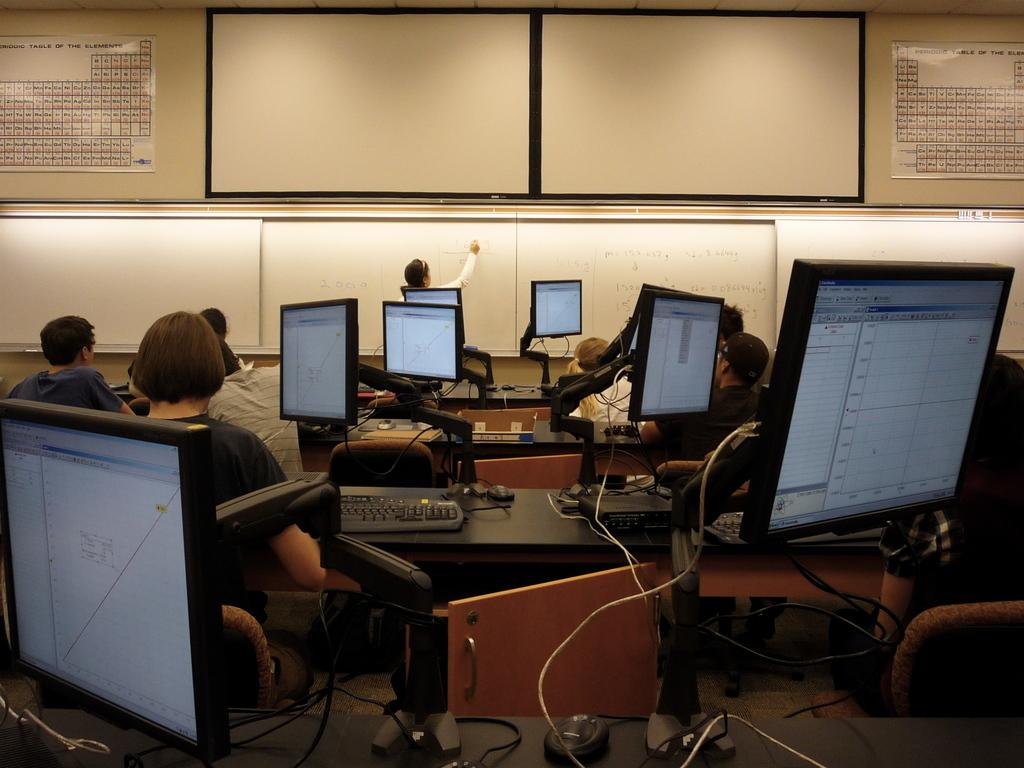What are the people in the image doing? There are people seated on chairs in the image. What objects are on the table in the image? There are monitors and keyboards on the table in the image. What type of writing surface is present in the image? There are whiteboards in the image. What is the woman in the image doing? A woman is writing on a whiteboard in the image. What type of lace is draped over the monitors in the image? There is no lace present in the image; the monitors are not covered by any fabric. 